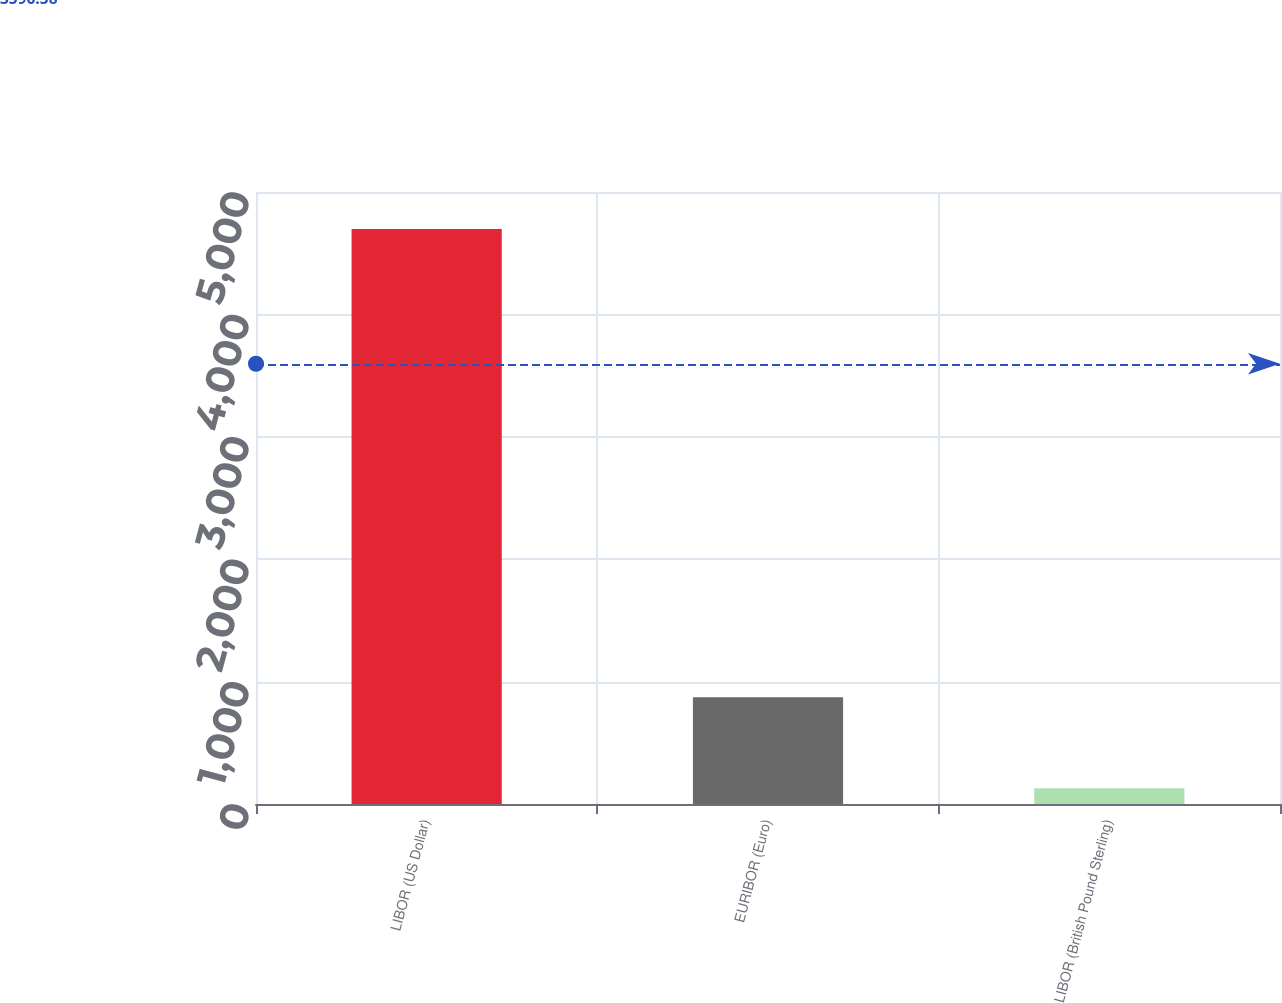<chart> <loc_0><loc_0><loc_500><loc_500><bar_chart><fcel>LIBOR (US Dollar)<fcel>EURIBOR (Euro)<fcel>LIBOR (British Pound Sterling)<nl><fcel>4697<fcel>872<fcel>128<nl></chart> 